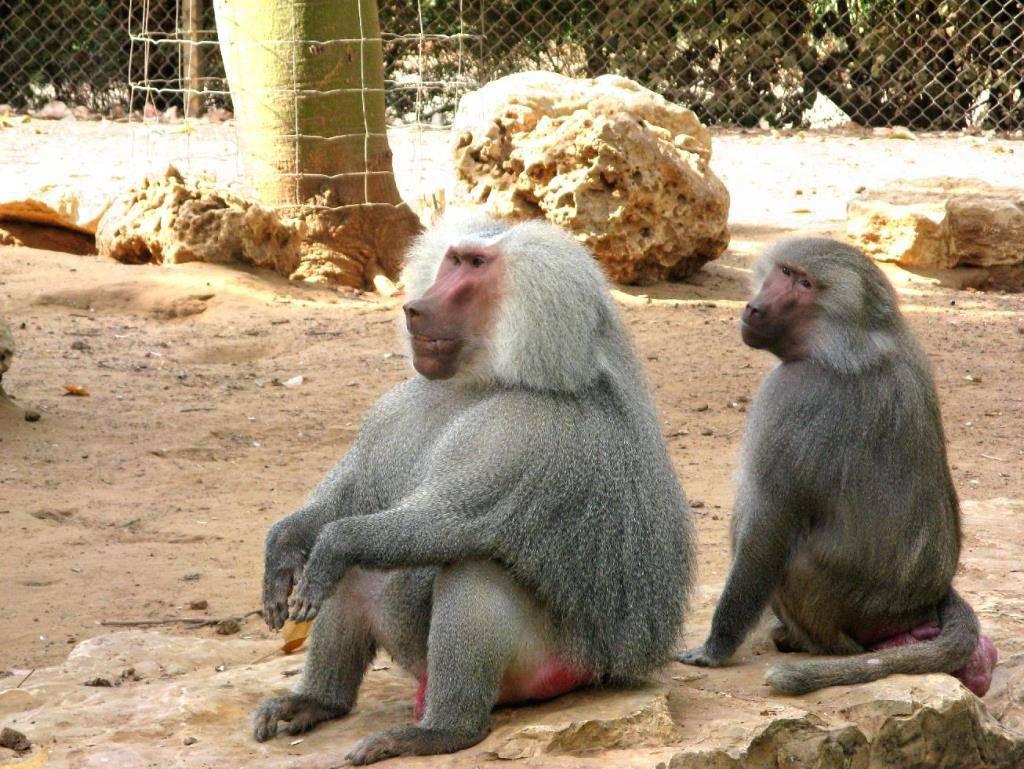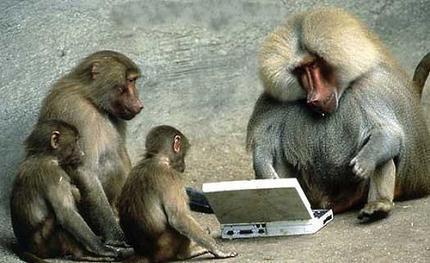The first image is the image on the left, the second image is the image on the right. For the images shown, is this caption "There are at most 4 monkeys in total" true? Answer yes or no. No. 